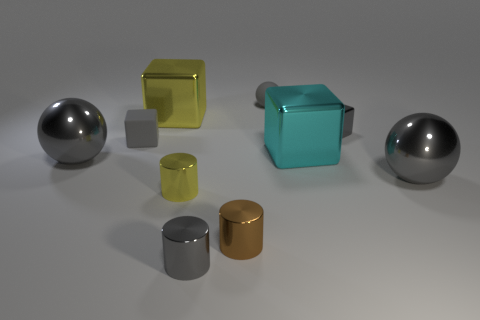Subtract all cylinders. How many objects are left? 7 Subtract all tiny matte spheres. Subtract all cyan things. How many objects are left? 8 Add 3 large spheres. How many large spheres are left? 5 Add 9 brown metallic cylinders. How many brown metallic cylinders exist? 10 Subtract 0 green balls. How many objects are left? 10 